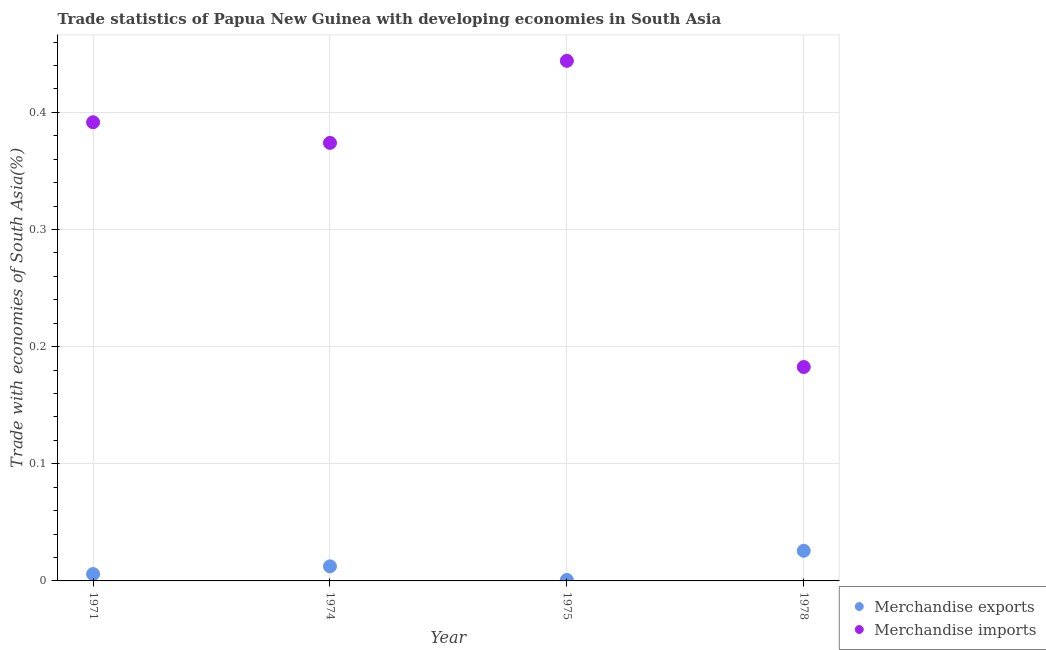How many different coloured dotlines are there?
Give a very brief answer. 2. What is the merchandise exports in 1974?
Offer a very short reply. 0.01. Across all years, what is the maximum merchandise exports?
Provide a succinct answer. 0.03. Across all years, what is the minimum merchandise imports?
Keep it short and to the point. 0.18. In which year was the merchandise exports maximum?
Provide a succinct answer. 1978. In which year was the merchandise imports minimum?
Offer a very short reply. 1978. What is the total merchandise imports in the graph?
Provide a succinct answer. 1.39. What is the difference between the merchandise imports in 1975 and that in 1978?
Offer a very short reply. 0.26. What is the difference between the merchandise imports in 1978 and the merchandise exports in 1971?
Keep it short and to the point. 0.18. What is the average merchandise imports per year?
Keep it short and to the point. 0.35. In the year 1975, what is the difference between the merchandise imports and merchandise exports?
Provide a succinct answer. 0.44. What is the ratio of the merchandise exports in 1971 to that in 1975?
Ensure brevity in your answer.  6.95. What is the difference between the highest and the second highest merchandise exports?
Your answer should be very brief. 0.01. What is the difference between the highest and the lowest merchandise imports?
Your answer should be very brief. 0.26. How many dotlines are there?
Provide a short and direct response. 2. How many years are there in the graph?
Your response must be concise. 4. What is the difference between two consecutive major ticks on the Y-axis?
Keep it short and to the point. 0.1. Are the values on the major ticks of Y-axis written in scientific E-notation?
Give a very brief answer. No. Where does the legend appear in the graph?
Offer a terse response. Bottom right. How are the legend labels stacked?
Your answer should be very brief. Vertical. What is the title of the graph?
Provide a succinct answer. Trade statistics of Papua New Guinea with developing economies in South Asia. What is the label or title of the Y-axis?
Ensure brevity in your answer.  Trade with economies of South Asia(%). What is the Trade with economies of South Asia(%) in Merchandise exports in 1971?
Provide a short and direct response. 0.01. What is the Trade with economies of South Asia(%) of Merchandise imports in 1971?
Ensure brevity in your answer.  0.39. What is the Trade with economies of South Asia(%) in Merchandise exports in 1974?
Keep it short and to the point. 0.01. What is the Trade with economies of South Asia(%) of Merchandise imports in 1974?
Your response must be concise. 0.37. What is the Trade with economies of South Asia(%) in Merchandise exports in 1975?
Give a very brief answer. 0. What is the Trade with economies of South Asia(%) in Merchandise imports in 1975?
Your answer should be compact. 0.44. What is the Trade with economies of South Asia(%) of Merchandise exports in 1978?
Offer a terse response. 0.03. What is the Trade with economies of South Asia(%) in Merchandise imports in 1978?
Provide a succinct answer. 0.18. Across all years, what is the maximum Trade with economies of South Asia(%) of Merchandise exports?
Your answer should be very brief. 0.03. Across all years, what is the maximum Trade with economies of South Asia(%) in Merchandise imports?
Offer a very short reply. 0.44. Across all years, what is the minimum Trade with economies of South Asia(%) in Merchandise exports?
Your answer should be very brief. 0. Across all years, what is the minimum Trade with economies of South Asia(%) in Merchandise imports?
Keep it short and to the point. 0.18. What is the total Trade with economies of South Asia(%) in Merchandise exports in the graph?
Keep it short and to the point. 0.04. What is the total Trade with economies of South Asia(%) in Merchandise imports in the graph?
Keep it short and to the point. 1.39. What is the difference between the Trade with economies of South Asia(%) in Merchandise exports in 1971 and that in 1974?
Provide a succinct answer. -0.01. What is the difference between the Trade with economies of South Asia(%) in Merchandise imports in 1971 and that in 1974?
Ensure brevity in your answer.  0.02. What is the difference between the Trade with economies of South Asia(%) in Merchandise exports in 1971 and that in 1975?
Make the answer very short. 0.01. What is the difference between the Trade with economies of South Asia(%) in Merchandise imports in 1971 and that in 1975?
Your response must be concise. -0.05. What is the difference between the Trade with economies of South Asia(%) of Merchandise exports in 1971 and that in 1978?
Offer a very short reply. -0.02. What is the difference between the Trade with economies of South Asia(%) of Merchandise imports in 1971 and that in 1978?
Give a very brief answer. 0.21. What is the difference between the Trade with economies of South Asia(%) of Merchandise exports in 1974 and that in 1975?
Provide a short and direct response. 0.01. What is the difference between the Trade with economies of South Asia(%) of Merchandise imports in 1974 and that in 1975?
Offer a very short reply. -0.07. What is the difference between the Trade with economies of South Asia(%) of Merchandise exports in 1974 and that in 1978?
Offer a terse response. -0.01. What is the difference between the Trade with economies of South Asia(%) in Merchandise imports in 1974 and that in 1978?
Your answer should be compact. 0.19. What is the difference between the Trade with economies of South Asia(%) of Merchandise exports in 1975 and that in 1978?
Provide a succinct answer. -0.02. What is the difference between the Trade with economies of South Asia(%) of Merchandise imports in 1975 and that in 1978?
Keep it short and to the point. 0.26. What is the difference between the Trade with economies of South Asia(%) of Merchandise exports in 1971 and the Trade with economies of South Asia(%) of Merchandise imports in 1974?
Keep it short and to the point. -0.37. What is the difference between the Trade with economies of South Asia(%) in Merchandise exports in 1971 and the Trade with economies of South Asia(%) in Merchandise imports in 1975?
Provide a short and direct response. -0.44. What is the difference between the Trade with economies of South Asia(%) of Merchandise exports in 1971 and the Trade with economies of South Asia(%) of Merchandise imports in 1978?
Offer a terse response. -0.18. What is the difference between the Trade with economies of South Asia(%) in Merchandise exports in 1974 and the Trade with economies of South Asia(%) in Merchandise imports in 1975?
Your answer should be very brief. -0.43. What is the difference between the Trade with economies of South Asia(%) of Merchandise exports in 1974 and the Trade with economies of South Asia(%) of Merchandise imports in 1978?
Your response must be concise. -0.17. What is the difference between the Trade with economies of South Asia(%) in Merchandise exports in 1975 and the Trade with economies of South Asia(%) in Merchandise imports in 1978?
Ensure brevity in your answer.  -0.18. What is the average Trade with economies of South Asia(%) in Merchandise exports per year?
Offer a terse response. 0.01. What is the average Trade with economies of South Asia(%) in Merchandise imports per year?
Your answer should be very brief. 0.35. In the year 1971, what is the difference between the Trade with economies of South Asia(%) in Merchandise exports and Trade with economies of South Asia(%) in Merchandise imports?
Provide a short and direct response. -0.39. In the year 1974, what is the difference between the Trade with economies of South Asia(%) in Merchandise exports and Trade with economies of South Asia(%) in Merchandise imports?
Make the answer very short. -0.36. In the year 1975, what is the difference between the Trade with economies of South Asia(%) of Merchandise exports and Trade with economies of South Asia(%) of Merchandise imports?
Ensure brevity in your answer.  -0.44. In the year 1978, what is the difference between the Trade with economies of South Asia(%) in Merchandise exports and Trade with economies of South Asia(%) in Merchandise imports?
Provide a short and direct response. -0.16. What is the ratio of the Trade with economies of South Asia(%) of Merchandise exports in 1971 to that in 1974?
Your response must be concise. 0.47. What is the ratio of the Trade with economies of South Asia(%) in Merchandise imports in 1971 to that in 1974?
Ensure brevity in your answer.  1.05. What is the ratio of the Trade with economies of South Asia(%) of Merchandise exports in 1971 to that in 1975?
Offer a very short reply. 6.95. What is the ratio of the Trade with economies of South Asia(%) of Merchandise imports in 1971 to that in 1975?
Provide a short and direct response. 0.88. What is the ratio of the Trade with economies of South Asia(%) of Merchandise exports in 1971 to that in 1978?
Your answer should be very brief. 0.23. What is the ratio of the Trade with economies of South Asia(%) in Merchandise imports in 1971 to that in 1978?
Offer a terse response. 2.14. What is the ratio of the Trade with economies of South Asia(%) of Merchandise exports in 1974 to that in 1975?
Offer a terse response. 14.77. What is the ratio of the Trade with economies of South Asia(%) of Merchandise imports in 1974 to that in 1975?
Provide a succinct answer. 0.84. What is the ratio of the Trade with economies of South Asia(%) in Merchandise exports in 1974 to that in 1978?
Your answer should be compact. 0.48. What is the ratio of the Trade with economies of South Asia(%) of Merchandise imports in 1974 to that in 1978?
Provide a succinct answer. 2.05. What is the ratio of the Trade with economies of South Asia(%) in Merchandise exports in 1975 to that in 1978?
Your response must be concise. 0.03. What is the ratio of the Trade with economies of South Asia(%) of Merchandise imports in 1975 to that in 1978?
Offer a terse response. 2.43. What is the difference between the highest and the second highest Trade with economies of South Asia(%) of Merchandise exports?
Offer a very short reply. 0.01. What is the difference between the highest and the second highest Trade with economies of South Asia(%) of Merchandise imports?
Offer a terse response. 0.05. What is the difference between the highest and the lowest Trade with economies of South Asia(%) in Merchandise exports?
Offer a terse response. 0.02. What is the difference between the highest and the lowest Trade with economies of South Asia(%) in Merchandise imports?
Your answer should be compact. 0.26. 